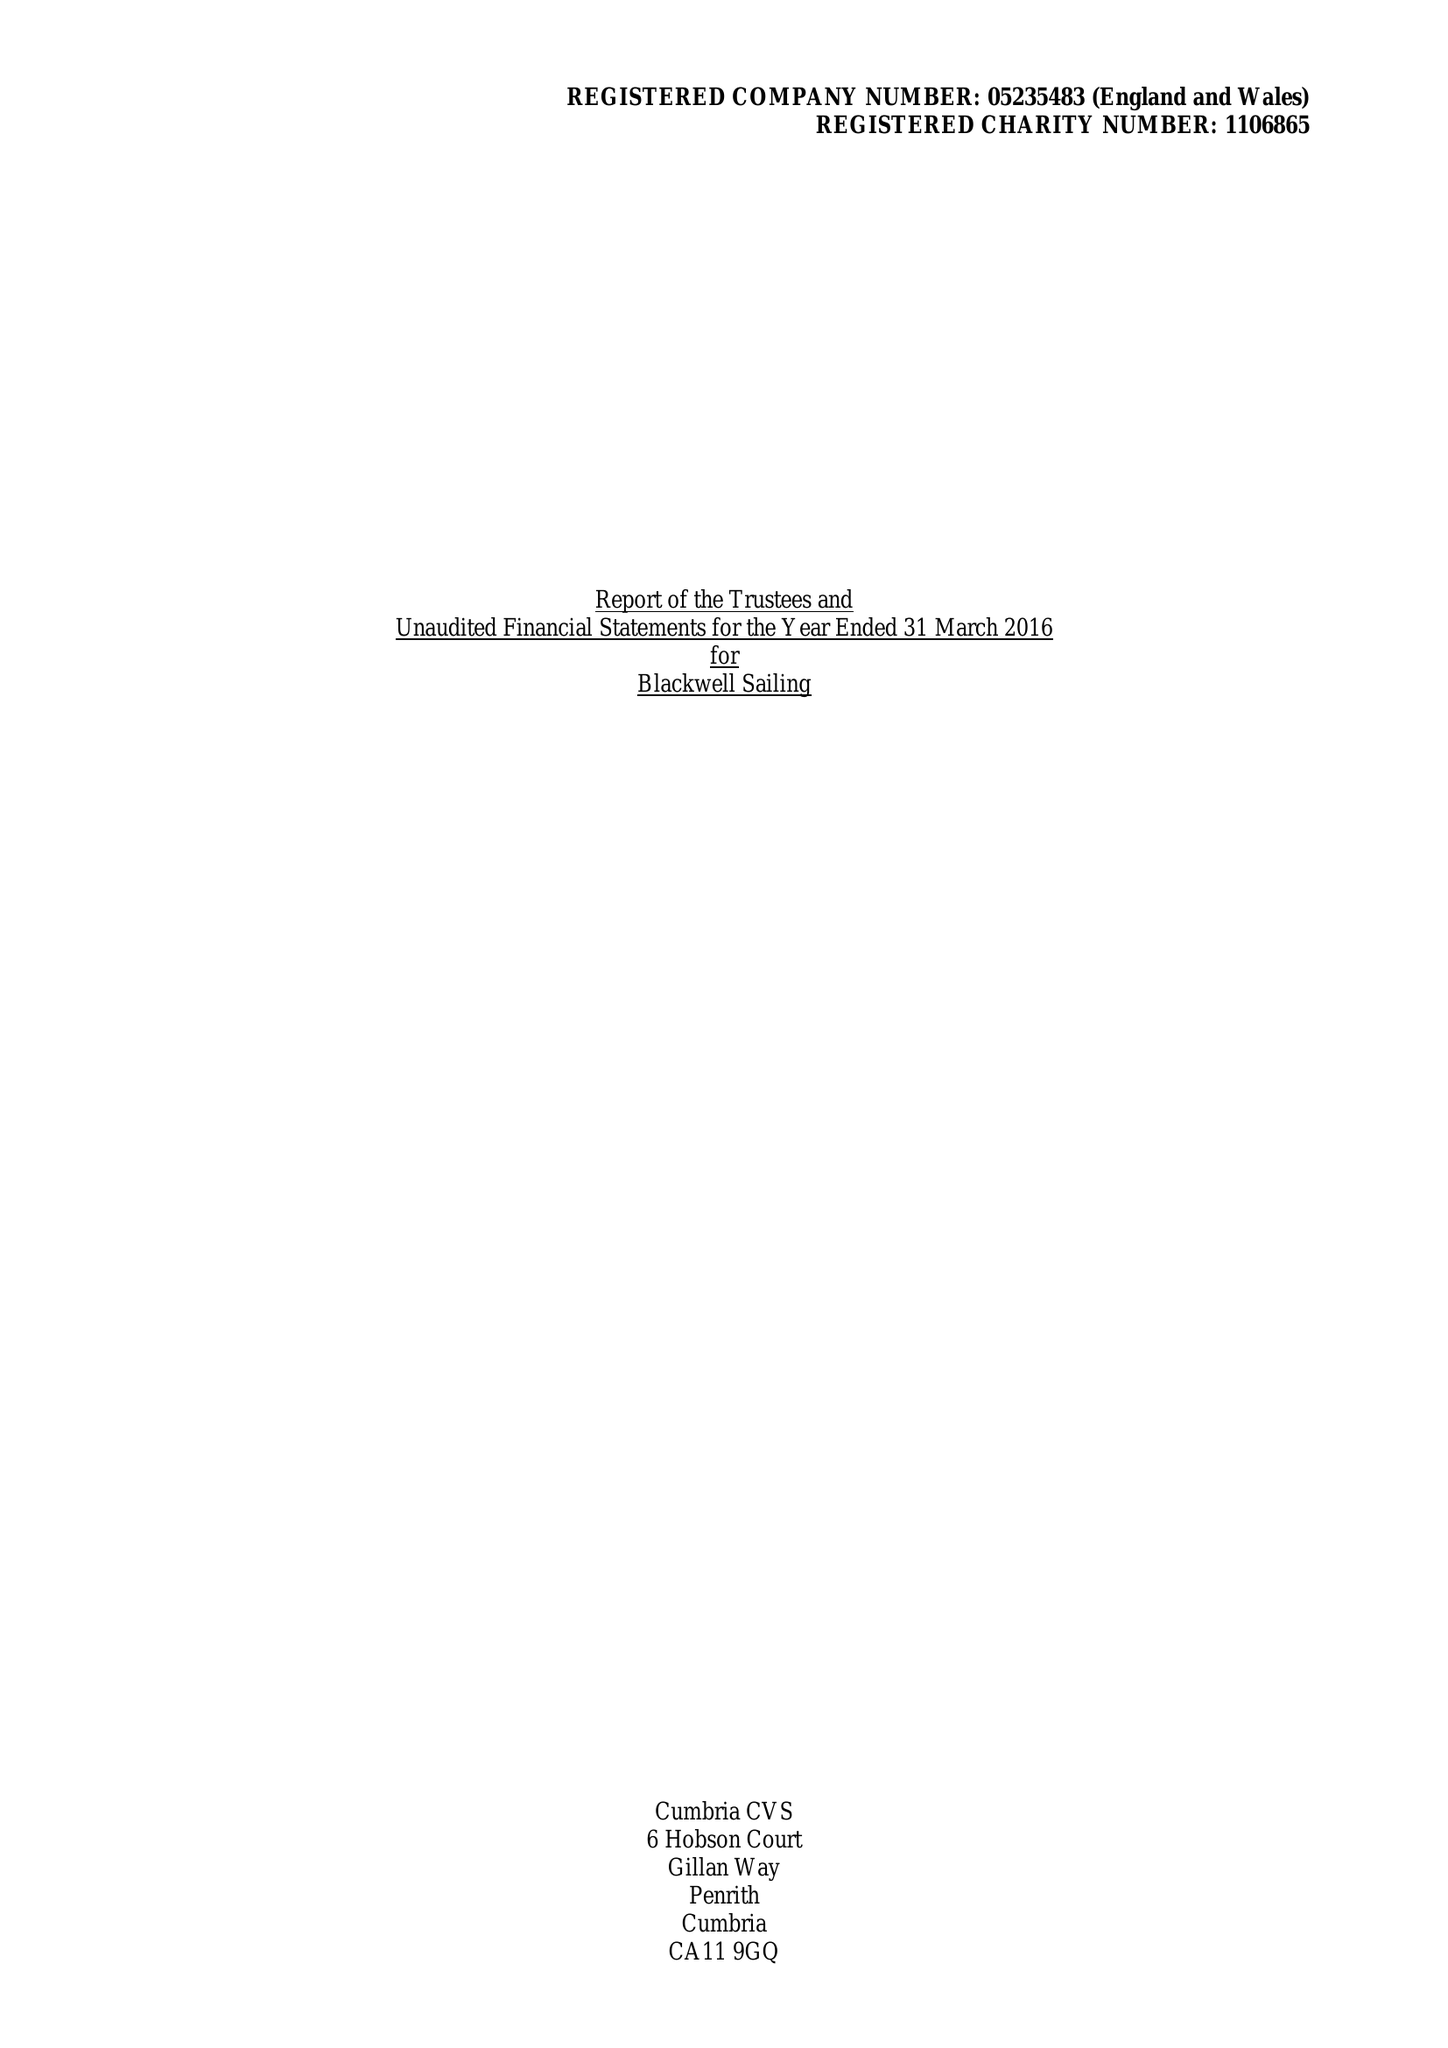What is the value for the address__street_line?
Answer the question using a single word or phrase. GLEBE ROAD 